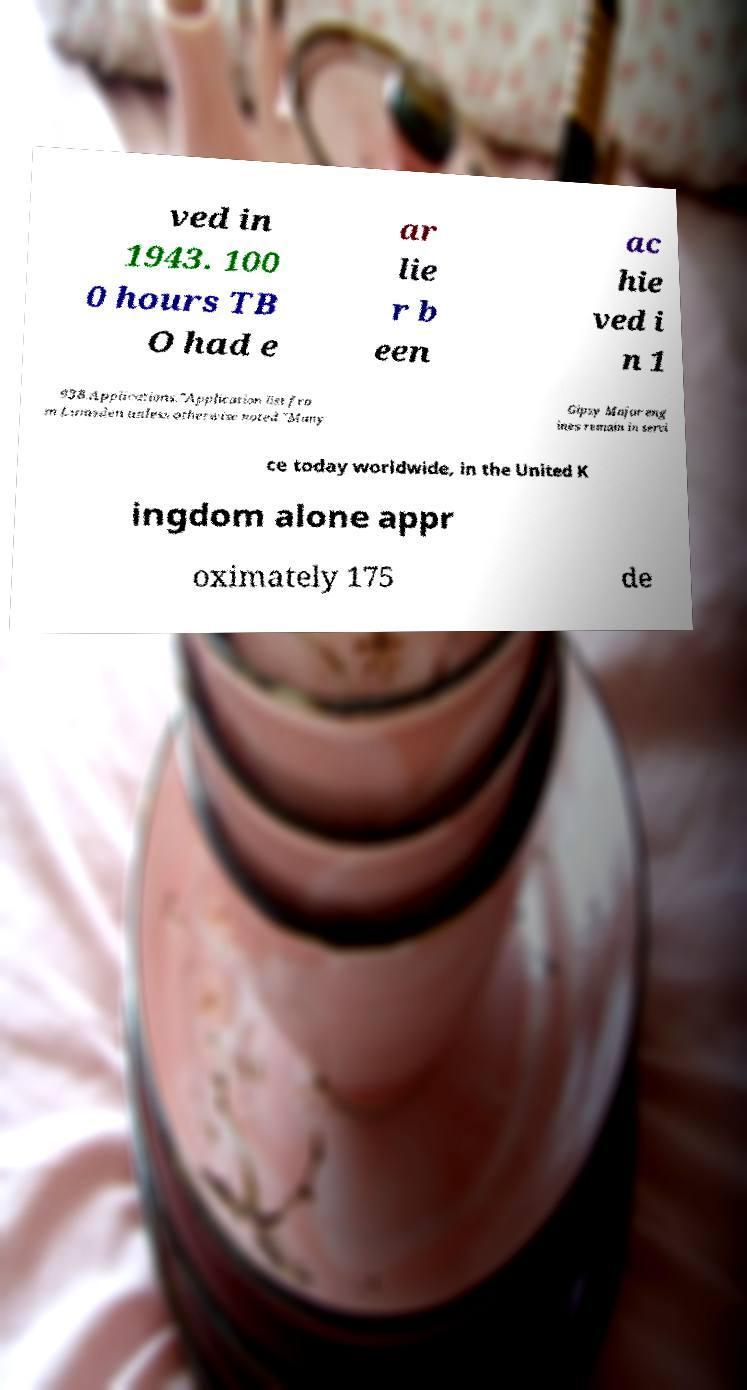Can you accurately transcribe the text from the provided image for me? ved in 1943. 100 0 hours TB O had e ar lie r b een ac hie ved i n 1 938.Applications."Application list fro m Lumsden unless otherwise noted."Many Gipsy Major eng ines remain in servi ce today worldwide, in the United K ingdom alone appr oximately 175 de 